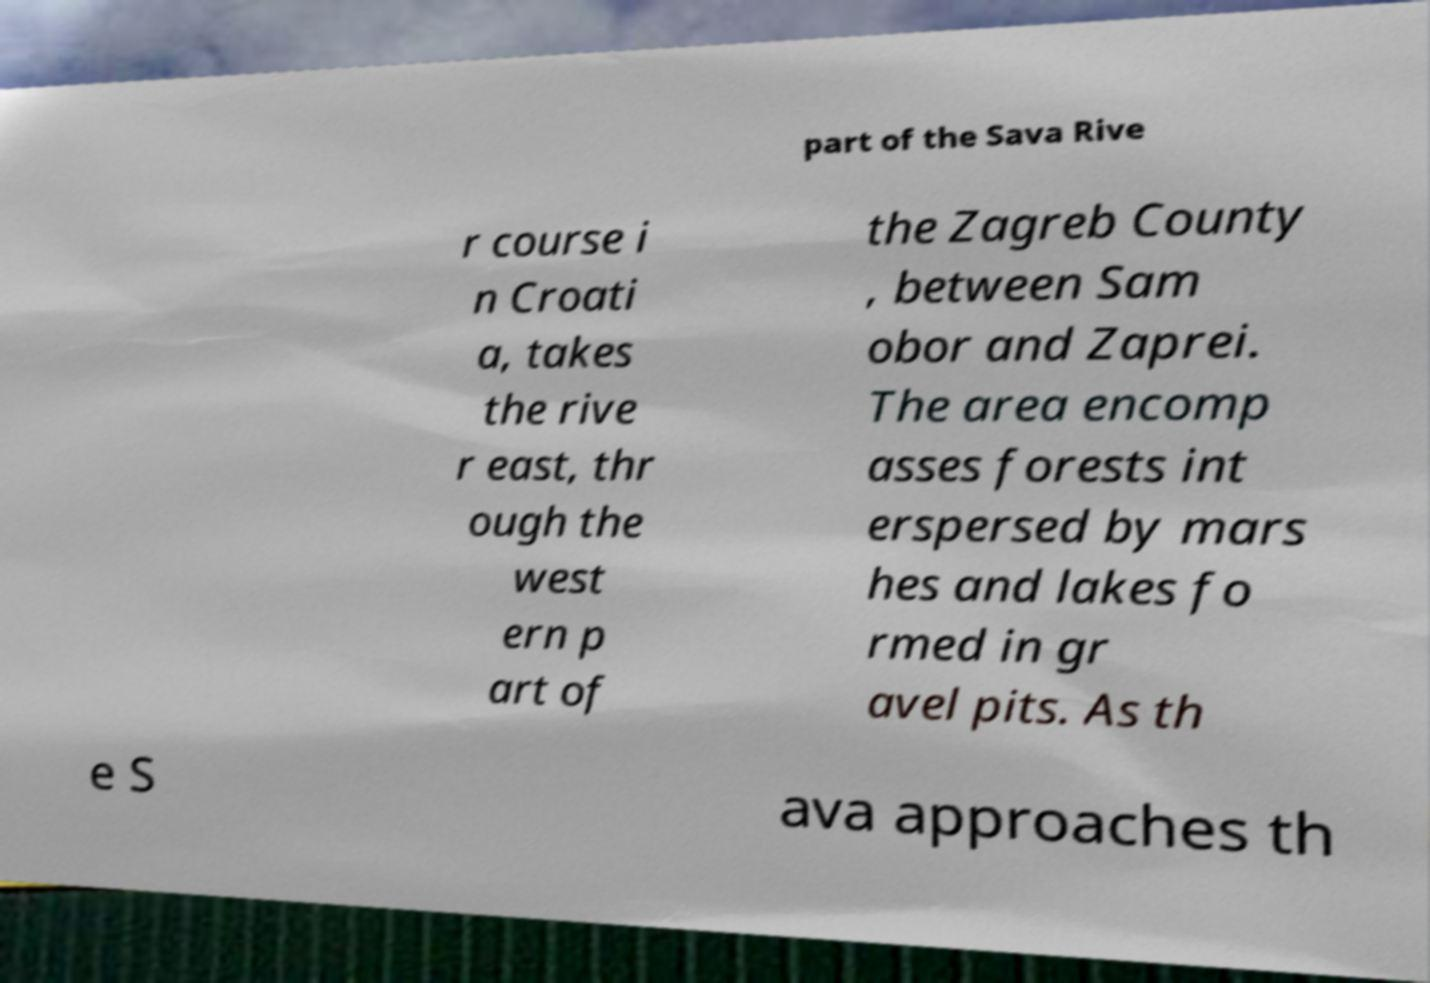What messages or text are displayed in this image? I need them in a readable, typed format. part of the Sava Rive r course i n Croati a, takes the rive r east, thr ough the west ern p art of the Zagreb County , between Sam obor and Zaprei. The area encomp asses forests int erspersed by mars hes and lakes fo rmed in gr avel pits. As th e S ava approaches th 